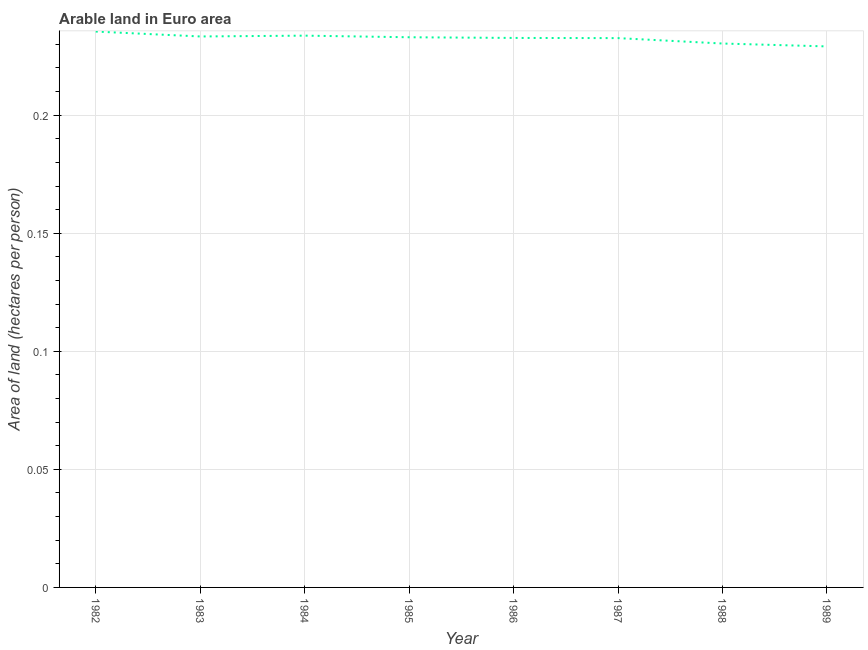What is the area of arable land in 1984?
Provide a short and direct response. 0.23. Across all years, what is the maximum area of arable land?
Ensure brevity in your answer.  0.24. Across all years, what is the minimum area of arable land?
Give a very brief answer. 0.23. In which year was the area of arable land minimum?
Offer a very short reply. 1989. What is the sum of the area of arable land?
Your answer should be compact. 1.86. What is the difference between the area of arable land in 1984 and 1988?
Offer a terse response. 0. What is the average area of arable land per year?
Ensure brevity in your answer.  0.23. What is the median area of arable land?
Offer a terse response. 0.23. Do a majority of the years between 1987 and 1985 (inclusive) have area of arable land greater than 0.07 hectares per person?
Offer a terse response. No. What is the ratio of the area of arable land in 1983 to that in 1986?
Give a very brief answer. 1. What is the difference between the highest and the second highest area of arable land?
Your response must be concise. 0. Is the sum of the area of arable land in 1982 and 1985 greater than the maximum area of arable land across all years?
Your answer should be very brief. Yes. What is the difference between the highest and the lowest area of arable land?
Keep it short and to the point. 0.01. Does the area of arable land monotonically increase over the years?
Keep it short and to the point. No. How many lines are there?
Your answer should be very brief. 1. How many years are there in the graph?
Ensure brevity in your answer.  8. What is the difference between two consecutive major ticks on the Y-axis?
Provide a short and direct response. 0.05. Are the values on the major ticks of Y-axis written in scientific E-notation?
Ensure brevity in your answer.  No. Does the graph contain any zero values?
Provide a succinct answer. No. Does the graph contain grids?
Offer a terse response. Yes. What is the title of the graph?
Your response must be concise. Arable land in Euro area. What is the label or title of the Y-axis?
Make the answer very short. Area of land (hectares per person). What is the Area of land (hectares per person) in 1982?
Offer a very short reply. 0.24. What is the Area of land (hectares per person) of 1983?
Your response must be concise. 0.23. What is the Area of land (hectares per person) in 1984?
Provide a succinct answer. 0.23. What is the Area of land (hectares per person) of 1985?
Provide a succinct answer. 0.23. What is the Area of land (hectares per person) in 1986?
Offer a terse response. 0.23. What is the Area of land (hectares per person) of 1987?
Your answer should be compact. 0.23. What is the Area of land (hectares per person) of 1988?
Your answer should be very brief. 0.23. What is the Area of land (hectares per person) in 1989?
Give a very brief answer. 0.23. What is the difference between the Area of land (hectares per person) in 1982 and 1983?
Keep it short and to the point. 0. What is the difference between the Area of land (hectares per person) in 1982 and 1984?
Your answer should be very brief. 0. What is the difference between the Area of land (hectares per person) in 1982 and 1985?
Offer a terse response. 0. What is the difference between the Area of land (hectares per person) in 1982 and 1986?
Your response must be concise. 0. What is the difference between the Area of land (hectares per person) in 1982 and 1987?
Your response must be concise. 0. What is the difference between the Area of land (hectares per person) in 1982 and 1988?
Your answer should be very brief. 0.01. What is the difference between the Area of land (hectares per person) in 1982 and 1989?
Your response must be concise. 0.01. What is the difference between the Area of land (hectares per person) in 1983 and 1984?
Provide a short and direct response. -0. What is the difference between the Area of land (hectares per person) in 1983 and 1985?
Make the answer very short. 0. What is the difference between the Area of land (hectares per person) in 1983 and 1986?
Give a very brief answer. 0. What is the difference between the Area of land (hectares per person) in 1983 and 1987?
Ensure brevity in your answer.  0. What is the difference between the Area of land (hectares per person) in 1983 and 1988?
Give a very brief answer. 0. What is the difference between the Area of land (hectares per person) in 1983 and 1989?
Make the answer very short. 0. What is the difference between the Area of land (hectares per person) in 1984 and 1985?
Ensure brevity in your answer.  0. What is the difference between the Area of land (hectares per person) in 1984 and 1986?
Your answer should be compact. 0. What is the difference between the Area of land (hectares per person) in 1984 and 1987?
Make the answer very short. 0. What is the difference between the Area of land (hectares per person) in 1984 and 1988?
Your response must be concise. 0. What is the difference between the Area of land (hectares per person) in 1984 and 1989?
Your answer should be very brief. 0. What is the difference between the Area of land (hectares per person) in 1985 and 1986?
Offer a very short reply. 0. What is the difference between the Area of land (hectares per person) in 1985 and 1987?
Make the answer very short. 0. What is the difference between the Area of land (hectares per person) in 1985 and 1988?
Make the answer very short. 0. What is the difference between the Area of land (hectares per person) in 1985 and 1989?
Make the answer very short. 0. What is the difference between the Area of land (hectares per person) in 1986 and 1987?
Provide a succinct answer. 8e-5. What is the difference between the Area of land (hectares per person) in 1986 and 1988?
Give a very brief answer. 0. What is the difference between the Area of land (hectares per person) in 1986 and 1989?
Your response must be concise. 0. What is the difference between the Area of land (hectares per person) in 1987 and 1988?
Keep it short and to the point. 0. What is the difference between the Area of land (hectares per person) in 1987 and 1989?
Make the answer very short. 0. What is the difference between the Area of land (hectares per person) in 1988 and 1989?
Provide a succinct answer. 0. What is the ratio of the Area of land (hectares per person) in 1982 to that in 1983?
Provide a short and direct response. 1.01. What is the ratio of the Area of land (hectares per person) in 1982 to that in 1984?
Provide a succinct answer. 1.01. What is the ratio of the Area of land (hectares per person) in 1982 to that in 1985?
Ensure brevity in your answer.  1.01. What is the ratio of the Area of land (hectares per person) in 1982 to that in 1986?
Provide a succinct answer. 1.01. What is the ratio of the Area of land (hectares per person) in 1982 to that in 1987?
Make the answer very short. 1.01. What is the ratio of the Area of land (hectares per person) in 1982 to that in 1988?
Offer a very short reply. 1.02. What is the ratio of the Area of land (hectares per person) in 1983 to that in 1986?
Your answer should be very brief. 1. What is the ratio of the Area of land (hectares per person) in 1983 to that in 1988?
Make the answer very short. 1.01. What is the ratio of the Area of land (hectares per person) in 1984 to that in 1987?
Give a very brief answer. 1. What is the ratio of the Area of land (hectares per person) in 1984 to that in 1989?
Offer a very short reply. 1.02. What is the ratio of the Area of land (hectares per person) in 1985 to that in 1987?
Make the answer very short. 1. What is the ratio of the Area of land (hectares per person) in 1985 to that in 1988?
Your answer should be very brief. 1.01. What is the ratio of the Area of land (hectares per person) in 1985 to that in 1989?
Keep it short and to the point. 1.02. What is the ratio of the Area of land (hectares per person) in 1986 to that in 1988?
Give a very brief answer. 1.01. What is the ratio of the Area of land (hectares per person) in 1986 to that in 1989?
Make the answer very short. 1.02. What is the ratio of the Area of land (hectares per person) in 1987 to that in 1988?
Your answer should be compact. 1.01. What is the ratio of the Area of land (hectares per person) in 1988 to that in 1989?
Offer a terse response. 1. 